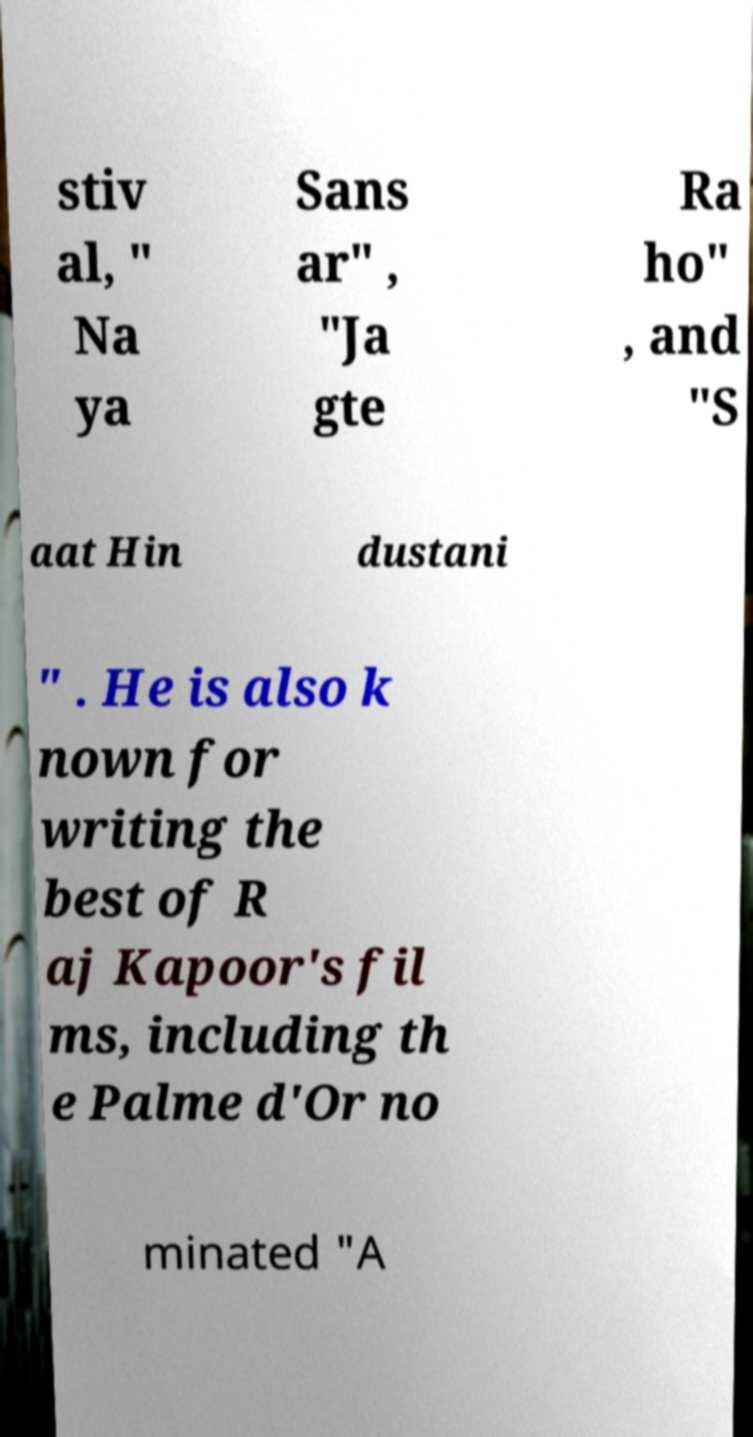Can you read and provide the text displayed in the image?This photo seems to have some interesting text. Can you extract and type it out for me? stiv al, " Na ya Sans ar" , "Ja gte Ra ho" , and "S aat Hin dustani " . He is also k nown for writing the best of R aj Kapoor's fil ms, including th e Palme d'Or no minated "A 